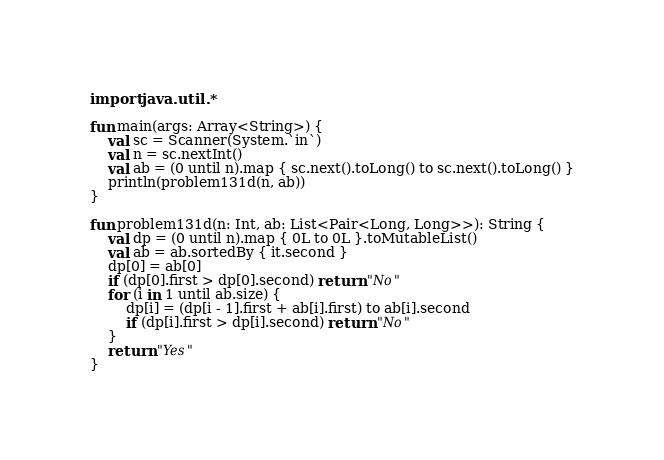Convert code to text. <code><loc_0><loc_0><loc_500><loc_500><_Kotlin_>import java.util.*

fun main(args: Array<String>) {
    val sc = Scanner(System.`in`)
    val n = sc.nextInt()
    val ab = (0 until n).map { sc.next().toLong() to sc.next().toLong() }
    println(problem131d(n, ab))
}

fun problem131d(n: Int, ab: List<Pair<Long, Long>>): String {
    val dp = (0 until n).map { 0L to 0L }.toMutableList()
    val ab = ab.sortedBy { it.second }
    dp[0] = ab[0]
    if (dp[0].first > dp[0].second) return "No"
    for (i in 1 until ab.size) {
        dp[i] = (dp[i - 1].first + ab[i].first) to ab[i].second
        if (dp[i].first > dp[i].second) return "No"
    }
    return "Yes"
}</code> 